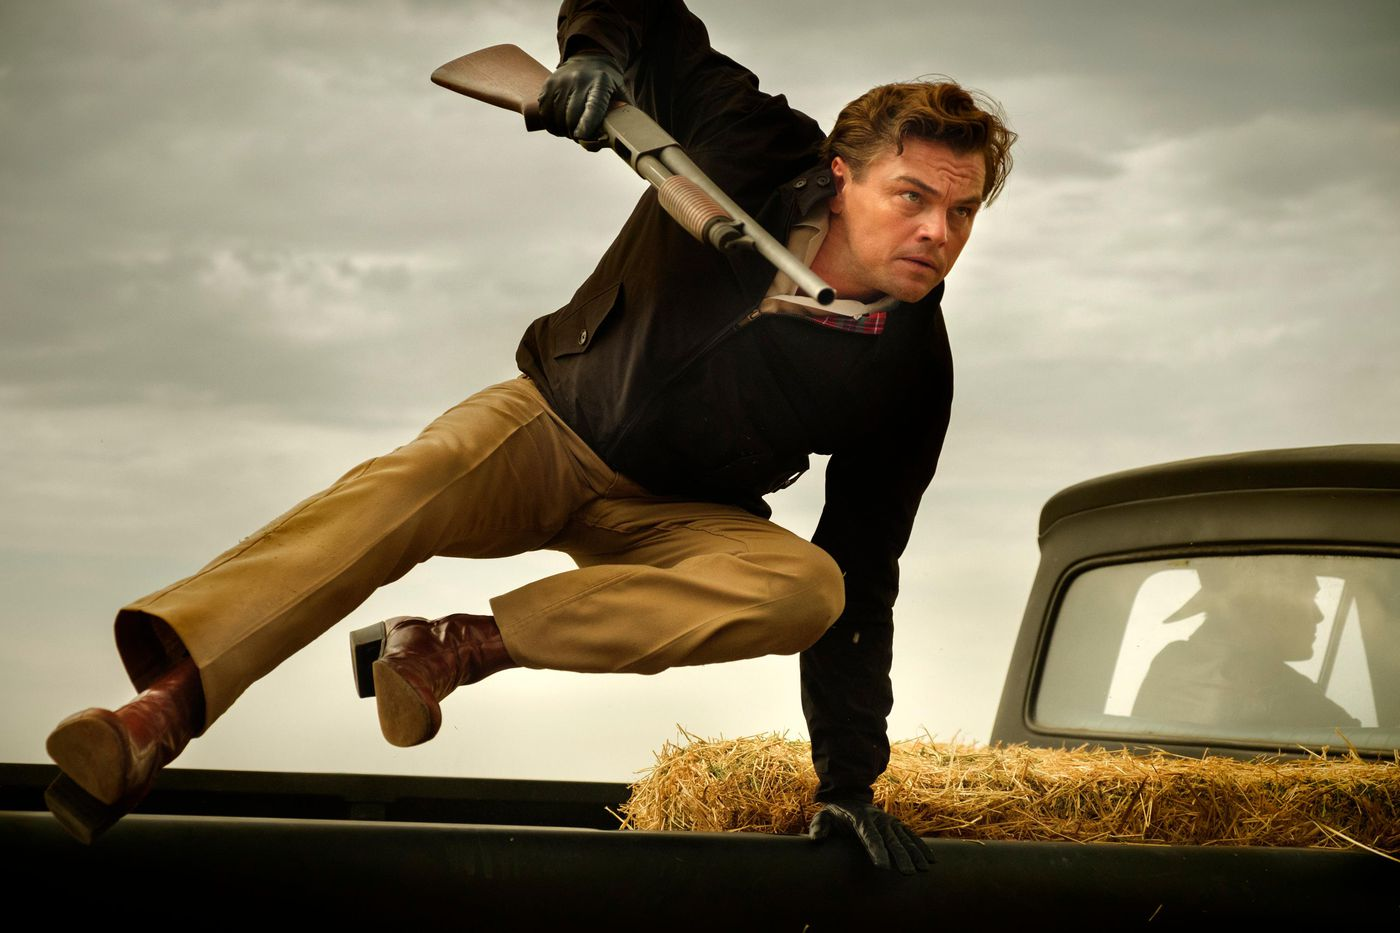If this were a part of a video game, what would be the player’s next objective? In a video game scenario, the player's next objective could be to navigate through a series of obstacles while avoiding or engaging enemies. They might need to use the vintage car for cover as they advance towards a specific target or goal. The mission could involve reaching a safe house, locating an important item, or rescuing a trapped character. The player would need to use strategy and quick reflexes to complete their objective while ensuring they remain unseen or protected from hostile forces. 